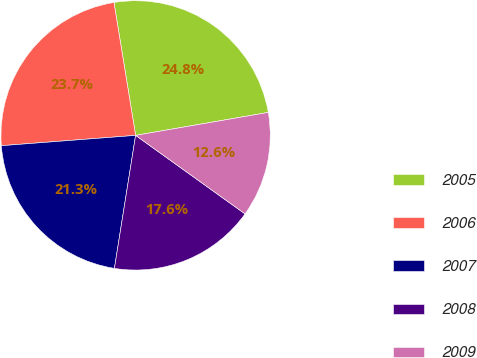<chart> <loc_0><loc_0><loc_500><loc_500><pie_chart><fcel>2005<fcel>2006<fcel>2007<fcel>2008<fcel>2009<nl><fcel>24.84%<fcel>23.65%<fcel>21.26%<fcel>17.61%<fcel>12.63%<nl></chart> 